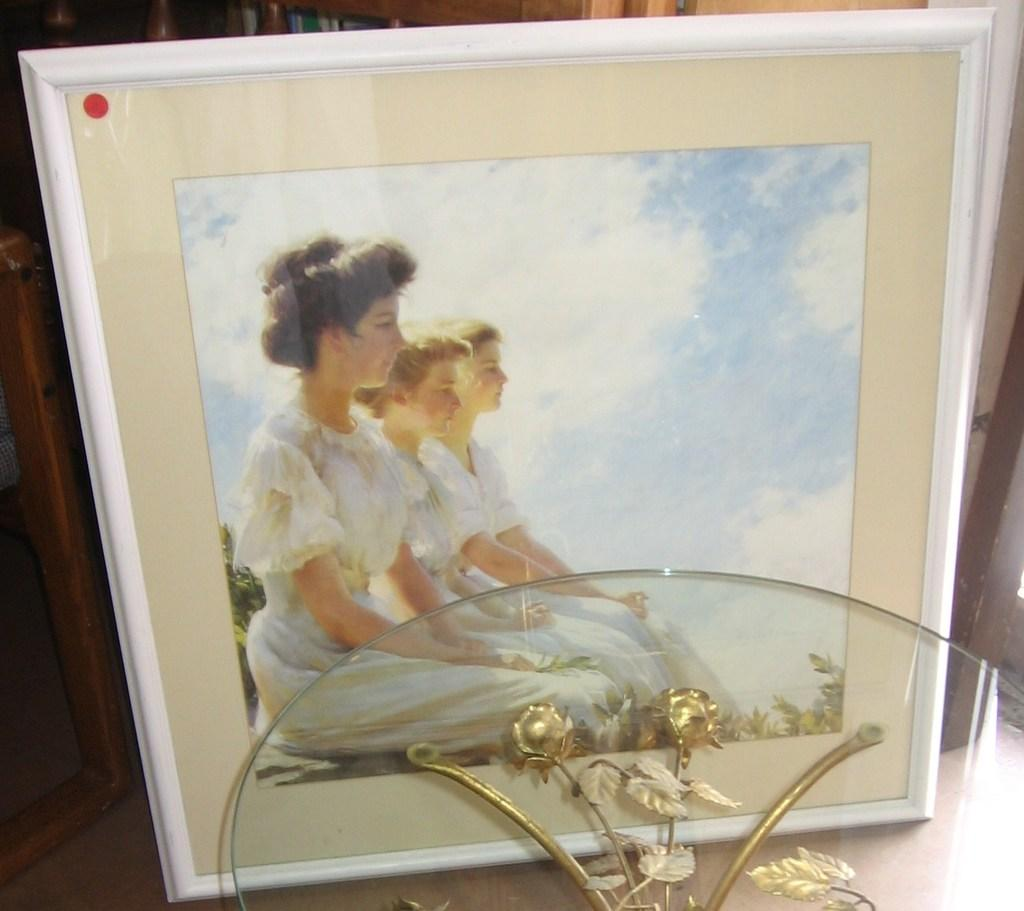What type of image is being described? The image is a photograph. What is the main subject of the photograph? There is a beautiful girl sitting in the image. What is the girl wearing? The girl is wearing a white dress. Are there any other people in the photograph? Yes, there are two other persons sitting beside the girl. What can be seen in the background of the photograph? The sky is visible at the top of the image, and it appears to be sunny. How many pigs are sleeping in the image? There are no pigs present in the image, and therefore no pigs can be seen sleeping. What color is the balloon that the girl is holding in the image? There is no balloon visible in the image, so it cannot be determined what color it might be. 